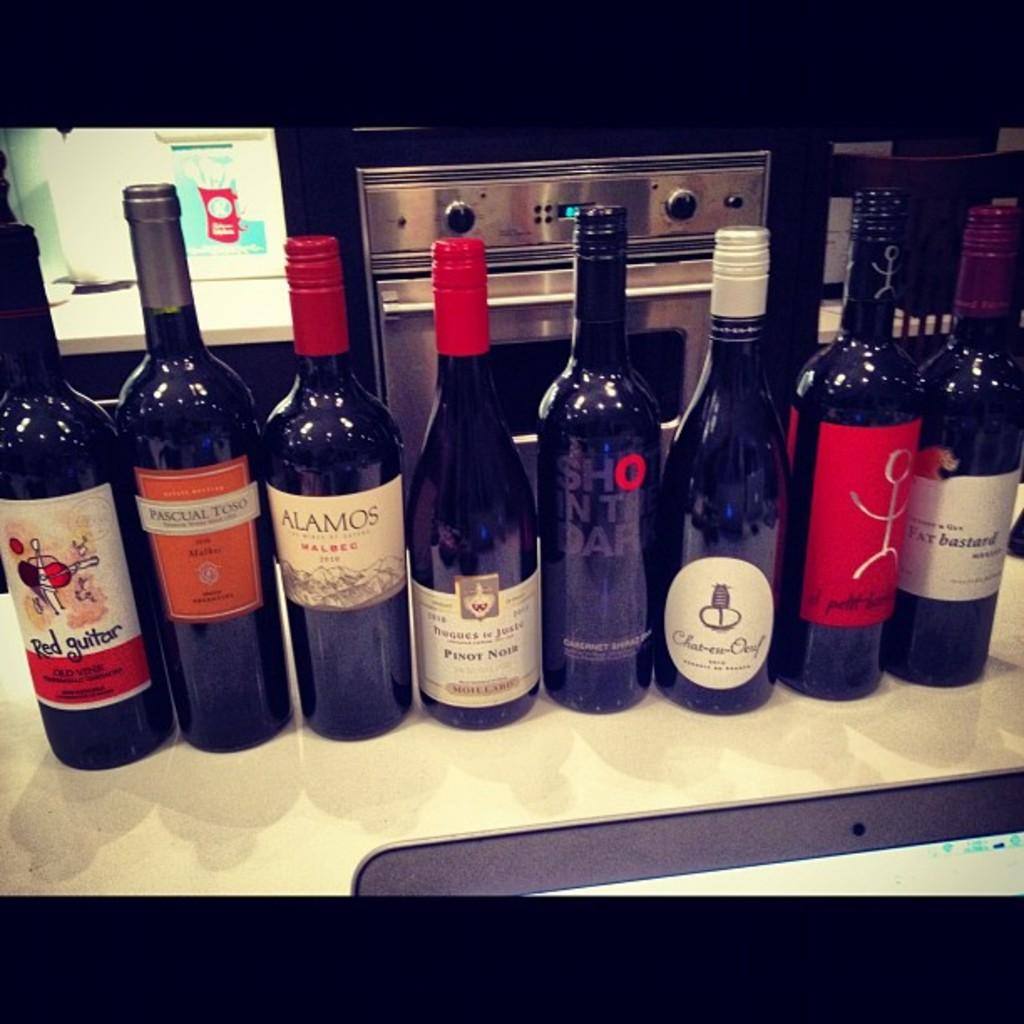<image>
Share a concise interpretation of the image provided. several wine bottles including Alamos are lined on a counter 